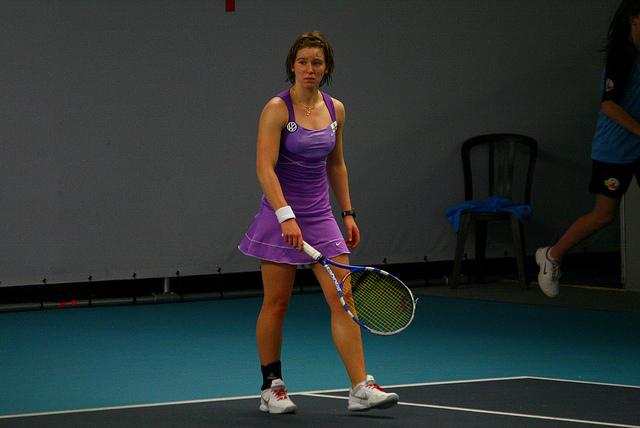What color is the woman's skirt?
Write a very short answer. Purple. Is this a male or female tennis player?
Give a very brief answer. Female. Are her shirt and the ball the same color?
Give a very brief answer. No. Is this game sponsored?
Answer briefly. No. What color is the woman's dress?
Keep it brief. Purple. Which ankle does the woman appear to be wearing a brace?
Be succinct. Right. What is the color of the woman outfit?
Keep it brief. Purple. Is this indoors or outside?
Give a very brief answer. Indoors. What brand shoes is the girl wearing?
Keep it brief. Nike. Is she happy or sad?
Answer briefly. Sad. What famous tennis player is this?
Answer briefly. Unknown. 